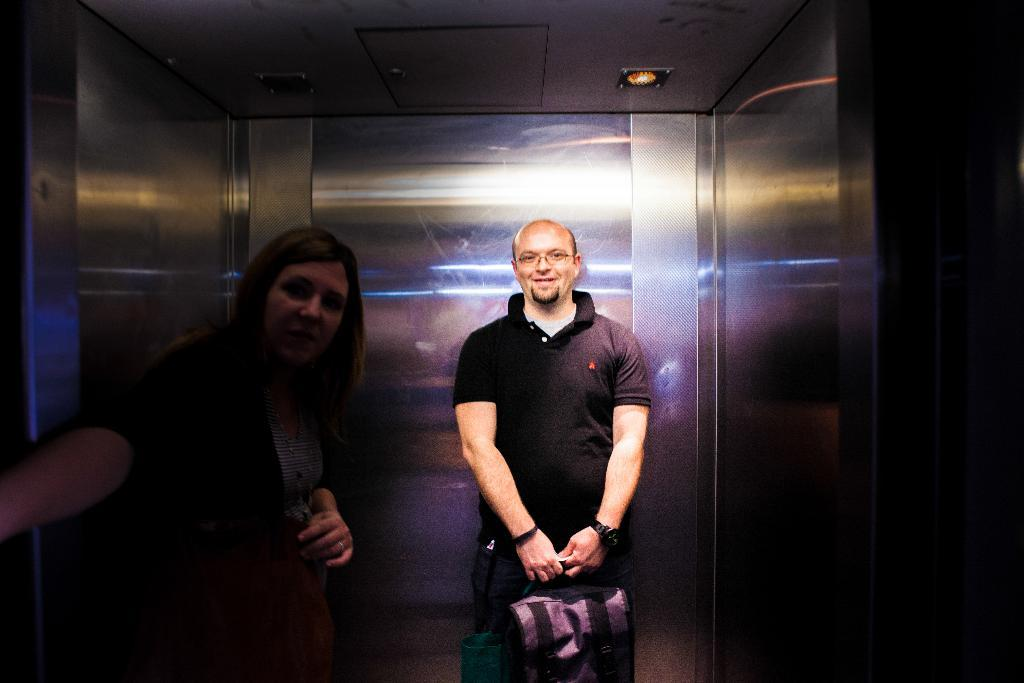How many people are in the image? There are two people in the image. Where are the people located in the image? The people are inside a lift. What is one of the people doing in the image? One of the people is holding bags. What can be seen at the top of the lift? There are lights at the top of the lift. What is a result of the lights in the lift? There are reflections of lights on the wall of the lift. What type of organization is responsible for the punishment of the people in the image? There is no indication of any organization or punishment in the image; it simply shows two people inside a lift. What is the quiver used for in the image? There is no quiver present in the image. 